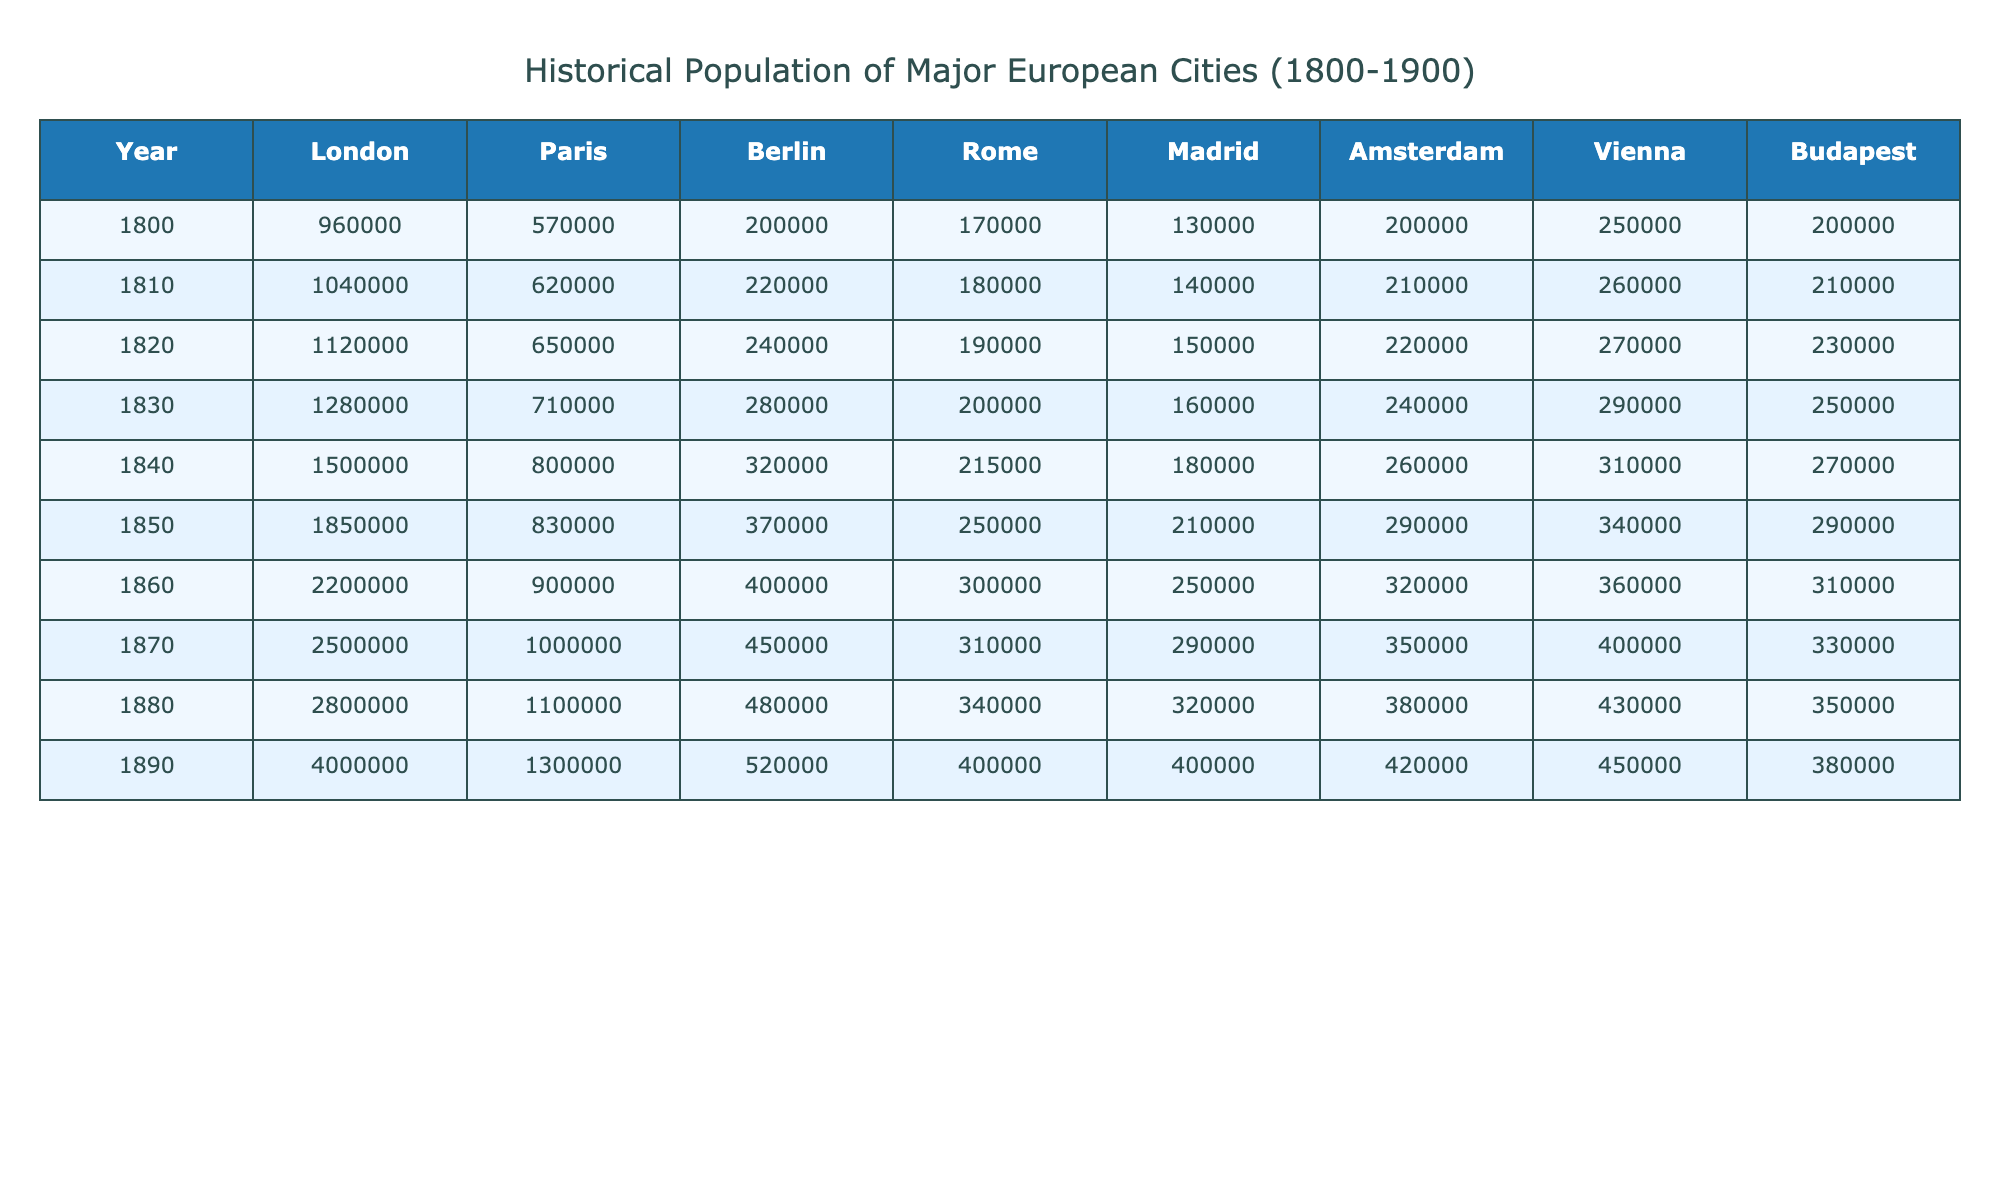What was the population of London in 1850? In the column for London, we look for the row corresponding to the year 1850, which shows the population to be 1,850,000.
Answer: 1,850,000 What was the difference in population between Paris and Berlin in 1890? From the table, in 1890, Paris had a population of 1,300,000 and Berlin had 520,000. The difference is calculated as 1,300,000 - 520,000 = 780,000.
Answer: 780,000 What was the average population of Madrid over the given years? To calculate the average population of Madrid from 1800 to 1890, we sum the populations (130,000 + 140,000 + 150,000 + 180,000 + 210,000 + 250,000 + 290,000 + 320,000 + 400,000) = 1,880,000. Dividing this sum by the number of years (9), we get 1,880,000 / 9 = 208,888.89.
Answer: 208,889 Which city had the highest population in 1870? In the 1870 row of the table, we compare the populations of London (2,500,000), Paris (1,000,000), Berlin (450,000), Rome (310,000), Madrid (290,000), Amsterdam (350,000), Vienna (400,000), and Budapest (330,000). London had the highest population at 2,500,000.
Answer: London Was the population of Vienna greater than that of Budapest in 1860? In the column for Vienna in 1860, the population is 360,000 and for Budapest, it is 310,000. Since 360,000 is greater than 310,000, the statement is true.
Answer: Yes What was the total population of all cities in 1880? To find the total population in 1880, we add the populations of all cities: (2,800,000 + 1,100,000 + 480,000 + 340,000 + 320,000 + 380,000 + 430,000 + 350,000) = 7,200,000.
Answer: 7,200,000 How did the population of Rome change from 1800 to 1900? In 1800, Rome had a population of 170,000 and in 1900, it had 400,000. The change is calculated as 400,000 - 170,000 = 230,000, indicating an increase.
Answer: Increased by 230,000 Which city experienced the largest absolute population growth from 1800 to 1900? We calculate the growth for each city: London (4,000,000 - 960,000), Paris (1,300,000 - 570,000), Berlin (520,000 - 200,000), Rome (400,000 - 170,000), Madrid (400,000 - 130,000), Amsterdam (420,000 - 200,000), Vienna (450,000 - 250,000), Budapest (380,000 - 200,000). The largest growth is for London: 4,000,000 - 960,000 = 3,040,000.
Answer: London In 1840, did any city have a population over 300,000? Checking the row for 1840, we find the populations: London (1,500,000), Paris (800,000), Berlin (320,000), Rome (215,000), Madrid (180,000), Amsterdam (260,000), Vienna (310,000), Budapest (270,000). The cities over 300,000 are London, Paris, Berlin, and Vienna.
Answer: Yes What was the growth rate of population in London from 1800 to 1890? The population in 1800 was 960,000 and in 1890 it was 4,000,000. The growth is (4,000,000 - 960,000) / 960,000 * 100%. Calculating this gives (3,040,000 / 960,000) * 100% = 316.67%.
Answer: 316.67% 